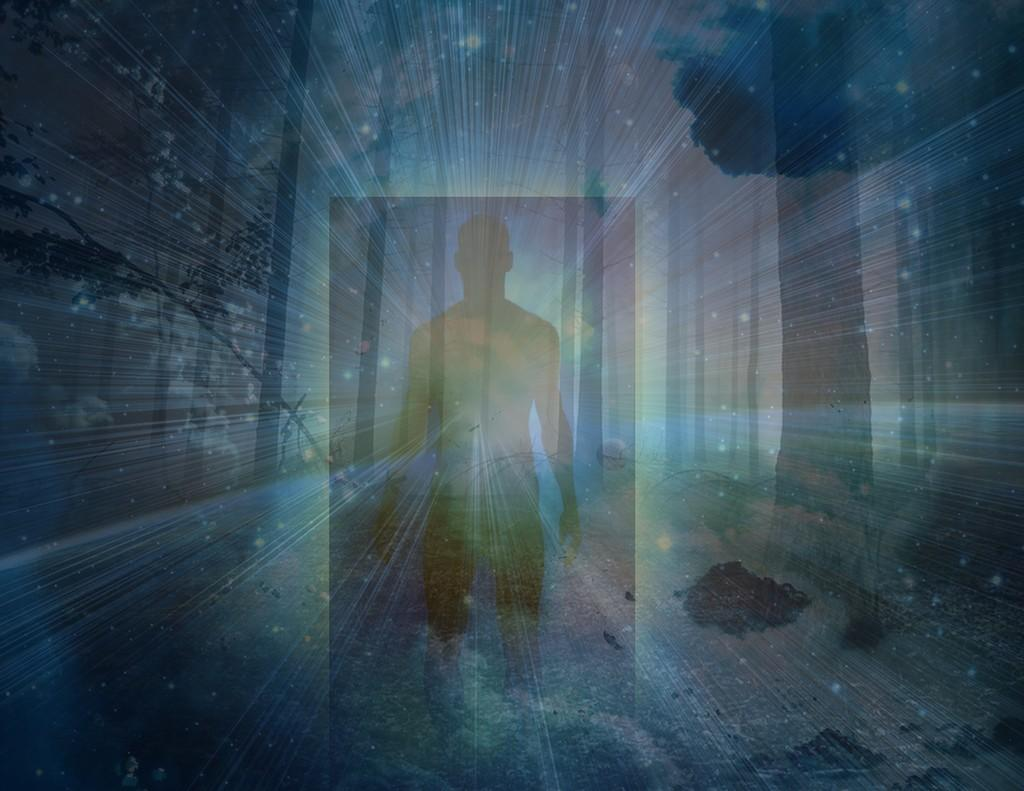What is present in the image? There is a person in the image. Can you describe the lighting in the image? There are rays visible in the image, which could be sunlight or some other form of light. How many mice are visible in the image? There are no mice present in the image. What type of care is the person providing in the image? The image does not show the person providing any care, so it cannot be determined from the image. 